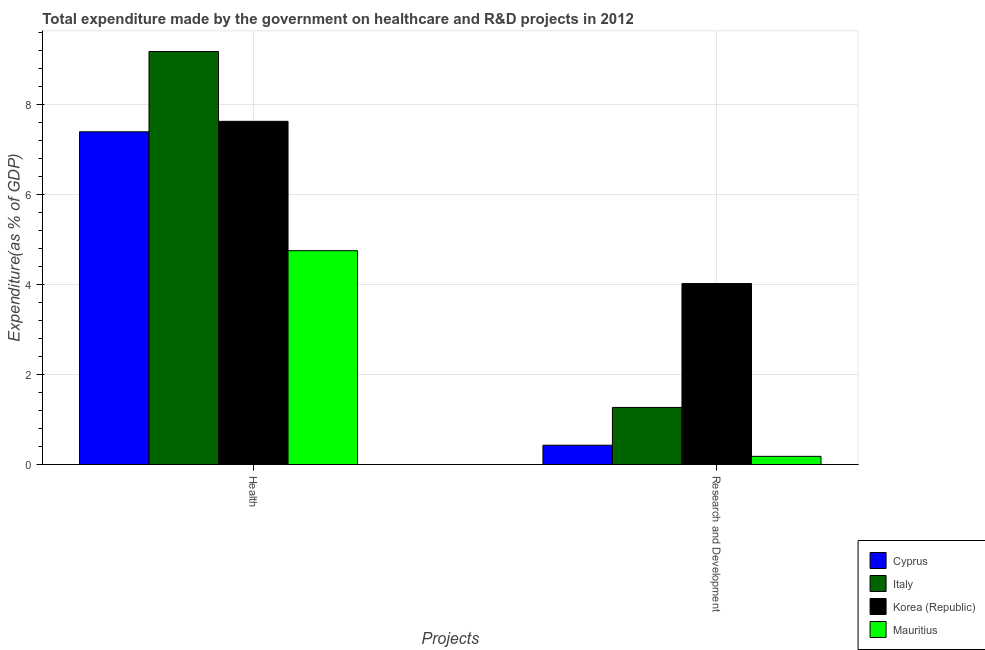How many different coloured bars are there?
Make the answer very short. 4. How many bars are there on the 1st tick from the left?
Provide a succinct answer. 4. What is the label of the 1st group of bars from the left?
Keep it short and to the point. Health. What is the expenditure in healthcare in Korea (Republic)?
Make the answer very short. 7.63. Across all countries, what is the maximum expenditure in healthcare?
Provide a succinct answer. 9.19. Across all countries, what is the minimum expenditure in healthcare?
Offer a very short reply. 4.76. In which country was the expenditure in healthcare maximum?
Ensure brevity in your answer.  Italy. In which country was the expenditure in healthcare minimum?
Provide a short and direct response. Mauritius. What is the total expenditure in r&d in the graph?
Keep it short and to the point. 5.91. What is the difference between the expenditure in r&d in Korea (Republic) and that in Italy?
Make the answer very short. 2.76. What is the difference between the expenditure in r&d in Italy and the expenditure in healthcare in Cyprus?
Provide a succinct answer. -6.13. What is the average expenditure in healthcare per country?
Provide a succinct answer. 7.24. What is the difference between the expenditure in r&d and expenditure in healthcare in Italy?
Provide a short and direct response. -7.92. What is the ratio of the expenditure in r&d in Korea (Republic) to that in Italy?
Offer a very short reply. 3.17. Is the expenditure in healthcare in Mauritius less than that in Cyprus?
Your answer should be compact. Yes. What does the 4th bar from the left in Research and Development represents?
Offer a terse response. Mauritius. What does the 1st bar from the right in Health represents?
Make the answer very short. Mauritius. How many bars are there?
Your response must be concise. 8. How many countries are there in the graph?
Your response must be concise. 4. Does the graph contain grids?
Offer a very short reply. Yes. Where does the legend appear in the graph?
Offer a terse response. Bottom right. What is the title of the graph?
Keep it short and to the point. Total expenditure made by the government on healthcare and R&D projects in 2012. What is the label or title of the X-axis?
Offer a terse response. Projects. What is the label or title of the Y-axis?
Offer a very short reply. Expenditure(as % of GDP). What is the Expenditure(as % of GDP) of Cyprus in Health?
Your answer should be very brief. 7.4. What is the Expenditure(as % of GDP) in Italy in Health?
Keep it short and to the point. 9.19. What is the Expenditure(as % of GDP) of Korea (Republic) in Health?
Provide a succinct answer. 7.63. What is the Expenditure(as % of GDP) of Mauritius in Health?
Ensure brevity in your answer.  4.76. What is the Expenditure(as % of GDP) in Cyprus in Research and Development?
Make the answer very short. 0.43. What is the Expenditure(as % of GDP) of Italy in Research and Development?
Your response must be concise. 1.27. What is the Expenditure(as % of GDP) in Korea (Republic) in Research and Development?
Your answer should be very brief. 4.03. What is the Expenditure(as % of GDP) in Mauritius in Research and Development?
Your answer should be compact. 0.18. Across all Projects, what is the maximum Expenditure(as % of GDP) in Cyprus?
Offer a terse response. 7.4. Across all Projects, what is the maximum Expenditure(as % of GDP) of Italy?
Your answer should be compact. 9.19. Across all Projects, what is the maximum Expenditure(as % of GDP) in Korea (Republic)?
Offer a very short reply. 7.63. Across all Projects, what is the maximum Expenditure(as % of GDP) in Mauritius?
Provide a short and direct response. 4.76. Across all Projects, what is the minimum Expenditure(as % of GDP) in Cyprus?
Provide a short and direct response. 0.43. Across all Projects, what is the minimum Expenditure(as % of GDP) of Italy?
Give a very brief answer. 1.27. Across all Projects, what is the minimum Expenditure(as % of GDP) of Korea (Republic)?
Make the answer very short. 4.03. Across all Projects, what is the minimum Expenditure(as % of GDP) in Mauritius?
Provide a succinct answer. 0.18. What is the total Expenditure(as % of GDP) of Cyprus in the graph?
Provide a short and direct response. 7.83. What is the total Expenditure(as % of GDP) of Italy in the graph?
Your answer should be very brief. 10.46. What is the total Expenditure(as % of GDP) in Korea (Republic) in the graph?
Offer a terse response. 11.66. What is the total Expenditure(as % of GDP) of Mauritius in the graph?
Keep it short and to the point. 4.94. What is the difference between the Expenditure(as % of GDP) of Cyprus in Health and that in Research and Development?
Your response must be concise. 6.97. What is the difference between the Expenditure(as % of GDP) in Italy in Health and that in Research and Development?
Provide a short and direct response. 7.92. What is the difference between the Expenditure(as % of GDP) in Korea (Republic) in Health and that in Research and Development?
Your response must be concise. 3.61. What is the difference between the Expenditure(as % of GDP) of Mauritius in Health and that in Research and Development?
Offer a terse response. 4.58. What is the difference between the Expenditure(as % of GDP) of Cyprus in Health and the Expenditure(as % of GDP) of Italy in Research and Development?
Give a very brief answer. 6.13. What is the difference between the Expenditure(as % of GDP) of Cyprus in Health and the Expenditure(as % of GDP) of Korea (Republic) in Research and Development?
Give a very brief answer. 3.38. What is the difference between the Expenditure(as % of GDP) in Cyprus in Health and the Expenditure(as % of GDP) in Mauritius in Research and Development?
Your answer should be compact. 7.22. What is the difference between the Expenditure(as % of GDP) of Italy in Health and the Expenditure(as % of GDP) of Korea (Republic) in Research and Development?
Provide a succinct answer. 5.16. What is the difference between the Expenditure(as % of GDP) in Italy in Health and the Expenditure(as % of GDP) in Mauritius in Research and Development?
Your answer should be compact. 9.01. What is the difference between the Expenditure(as % of GDP) in Korea (Republic) in Health and the Expenditure(as % of GDP) in Mauritius in Research and Development?
Keep it short and to the point. 7.45. What is the average Expenditure(as % of GDP) of Cyprus per Projects?
Offer a very short reply. 3.91. What is the average Expenditure(as % of GDP) of Italy per Projects?
Offer a very short reply. 5.23. What is the average Expenditure(as % of GDP) in Korea (Republic) per Projects?
Provide a short and direct response. 5.83. What is the average Expenditure(as % of GDP) of Mauritius per Projects?
Your answer should be compact. 2.47. What is the difference between the Expenditure(as % of GDP) of Cyprus and Expenditure(as % of GDP) of Italy in Health?
Make the answer very short. -1.79. What is the difference between the Expenditure(as % of GDP) in Cyprus and Expenditure(as % of GDP) in Korea (Republic) in Health?
Offer a very short reply. -0.23. What is the difference between the Expenditure(as % of GDP) of Cyprus and Expenditure(as % of GDP) of Mauritius in Health?
Keep it short and to the point. 2.64. What is the difference between the Expenditure(as % of GDP) of Italy and Expenditure(as % of GDP) of Korea (Republic) in Health?
Make the answer very short. 1.55. What is the difference between the Expenditure(as % of GDP) in Italy and Expenditure(as % of GDP) in Mauritius in Health?
Provide a short and direct response. 4.43. What is the difference between the Expenditure(as % of GDP) in Korea (Republic) and Expenditure(as % of GDP) in Mauritius in Health?
Ensure brevity in your answer.  2.88. What is the difference between the Expenditure(as % of GDP) in Cyprus and Expenditure(as % of GDP) in Italy in Research and Development?
Your answer should be compact. -0.84. What is the difference between the Expenditure(as % of GDP) in Cyprus and Expenditure(as % of GDP) in Korea (Republic) in Research and Development?
Keep it short and to the point. -3.6. What is the difference between the Expenditure(as % of GDP) of Cyprus and Expenditure(as % of GDP) of Mauritius in Research and Development?
Offer a very short reply. 0.25. What is the difference between the Expenditure(as % of GDP) in Italy and Expenditure(as % of GDP) in Korea (Republic) in Research and Development?
Provide a short and direct response. -2.76. What is the difference between the Expenditure(as % of GDP) of Italy and Expenditure(as % of GDP) of Mauritius in Research and Development?
Your answer should be very brief. 1.09. What is the difference between the Expenditure(as % of GDP) of Korea (Republic) and Expenditure(as % of GDP) of Mauritius in Research and Development?
Your answer should be compact. 3.84. What is the ratio of the Expenditure(as % of GDP) in Cyprus in Health to that in Research and Development?
Your answer should be compact. 17.24. What is the ratio of the Expenditure(as % of GDP) of Italy in Health to that in Research and Development?
Keep it short and to the point. 7.24. What is the ratio of the Expenditure(as % of GDP) of Korea (Republic) in Health to that in Research and Development?
Your answer should be compact. 1.9. What is the ratio of the Expenditure(as % of GDP) in Mauritius in Health to that in Research and Development?
Give a very brief answer. 26.24. What is the difference between the highest and the second highest Expenditure(as % of GDP) in Cyprus?
Your answer should be compact. 6.97. What is the difference between the highest and the second highest Expenditure(as % of GDP) in Italy?
Your answer should be compact. 7.92. What is the difference between the highest and the second highest Expenditure(as % of GDP) in Korea (Republic)?
Keep it short and to the point. 3.61. What is the difference between the highest and the second highest Expenditure(as % of GDP) of Mauritius?
Ensure brevity in your answer.  4.58. What is the difference between the highest and the lowest Expenditure(as % of GDP) in Cyprus?
Keep it short and to the point. 6.97. What is the difference between the highest and the lowest Expenditure(as % of GDP) of Italy?
Provide a succinct answer. 7.92. What is the difference between the highest and the lowest Expenditure(as % of GDP) of Korea (Republic)?
Your answer should be compact. 3.61. What is the difference between the highest and the lowest Expenditure(as % of GDP) in Mauritius?
Provide a short and direct response. 4.58. 